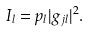<formula> <loc_0><loc_0><loc_500><loc_500>I _ { l } = p _ { l } | g _ { j l } | ^ { 2 } .</formula> 